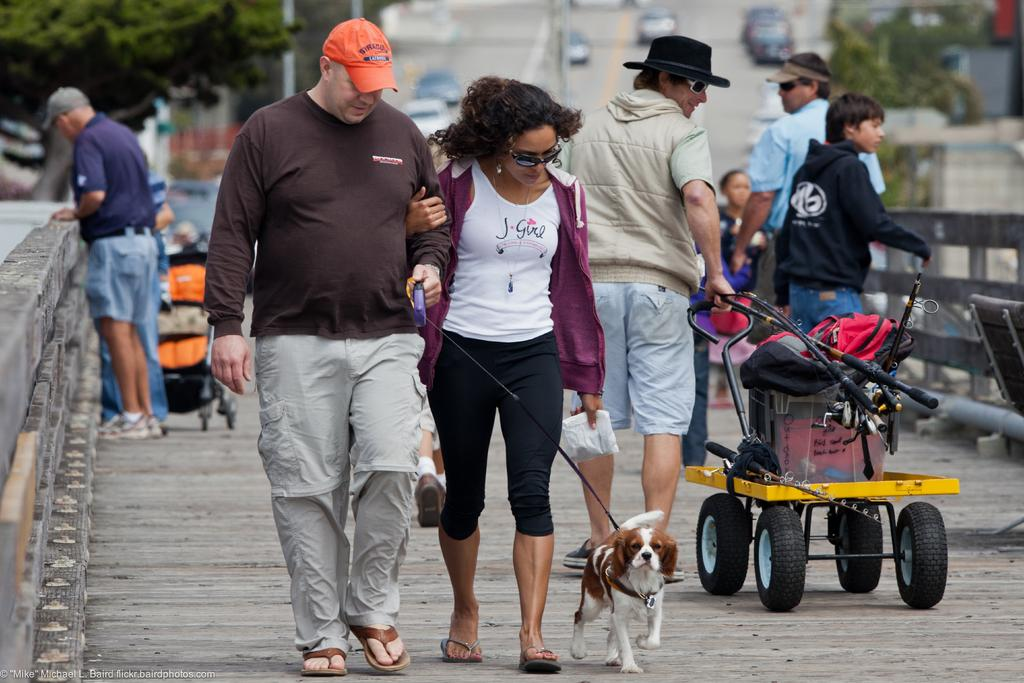How many people are in the image? There is a group of people in the image. Where are the people located in the image? The people are standing on a bridge. What other living creature is present in the image? There is a dog in the image. What type of transportation device is visible in the image? There is a stroller in the image. What can be seen in the background of the image? Vehicles are visible on the road and there are trees in the background. What type of cactus can be seen growing on the bridge in the image? There is no cactus present in the image; the background features trees, not cacti. 